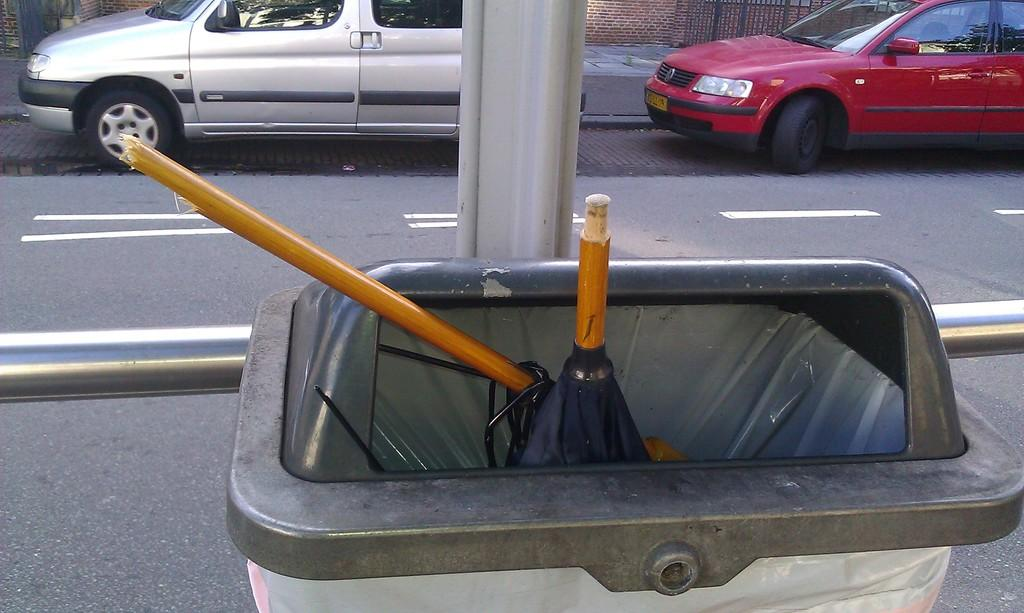What object is present in the image for waste disposal? There is a dustbin in the image. What type of pathway can be seen in the image? There is a road in the image. How many vehicles are visible in the image? There are two cars visible in the image. Can you tell me how many hills are visible in the image? There are no hills visible in the image; it features a dustbin, a road, and two cars. What decision is being made by the cars in the image? The image does not depict any decisions being made by the cars; they are simply parked or driving along the road. 